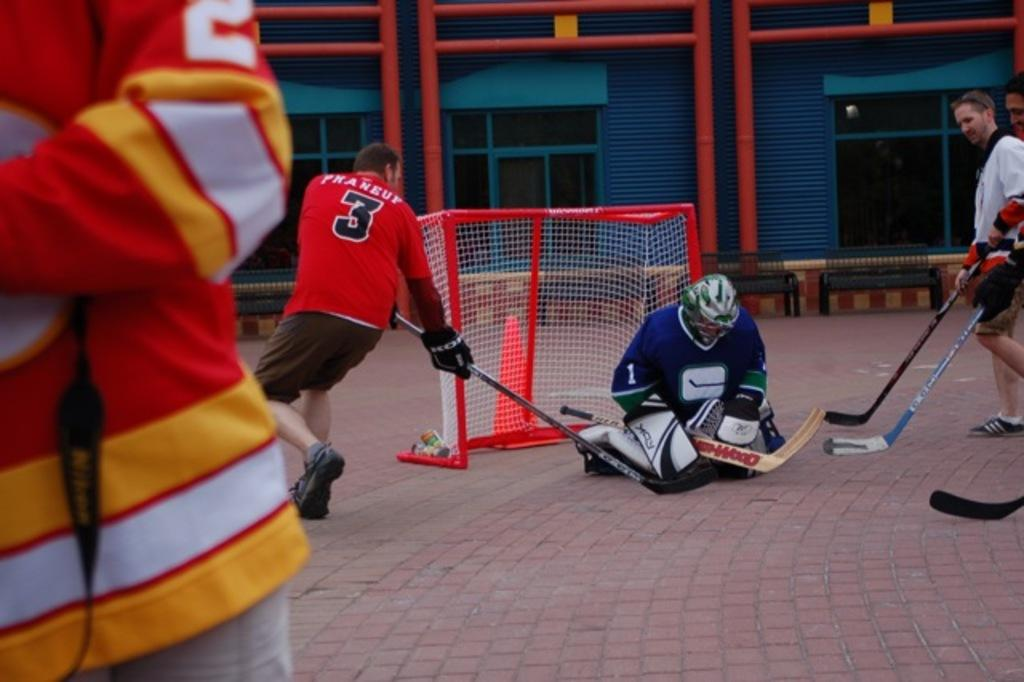<image>
Relay a brief, clear account of the picture shown. Hockey player wearing jersey number 3 is trying to hit the puck in the net. 